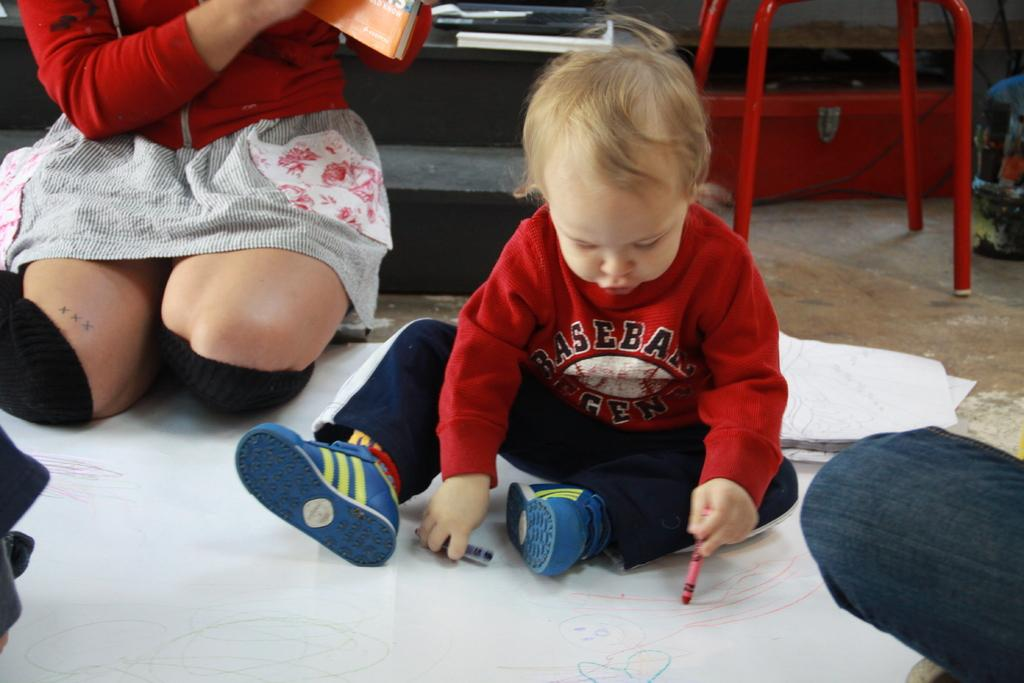What is the main subject of the image? The main subject of the image is a baby. What is the baby doing in the image? The baby is drawing on a white paper. What tools is the baby using for drawing? The baby is using crayons. Is there anyone else present in the image? Yes, there is a person sitting near the baby. What is the person holding? The person is holding a book. Is the baby attacking the floor with the crayons in the image? No, the baby is not attacking the floor with the crayons in the image; they are simply drawing on a white paper. 